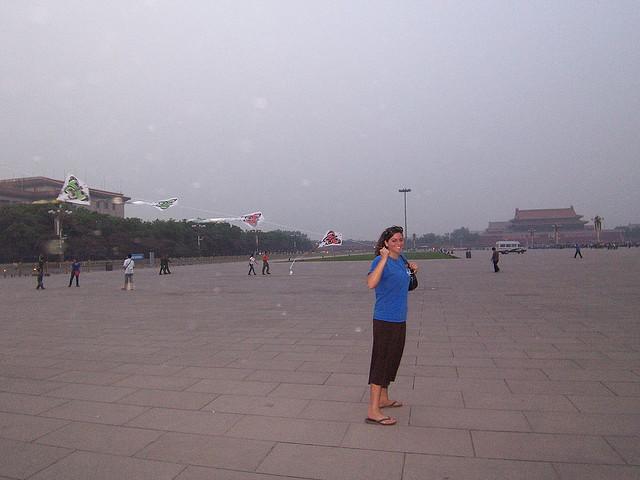What are the marks in the snow?
Concise answer only. No snow. Is she flying her kite in a city park?
Quick response, please. Yes. How many people are in this picture?
Write a very short answer. 10. What hand sign is she making?
Concise answer only. Fist. How many kites are being flown?
Give a very brief answer. 4. Is this what they wore in old days to play ball?
Give a very brief answer. No. Is this lady wearing a dress?
Answer briefly. No. What is cast?
Keep it brief. Overcast. What is the color of the clouds?
Keep it brief. Gray. What is the person standing on?
Short answer required. Ground. What color is the sky?
Concise answer only. Gray. Are these all adults?
Short answer required. Yes. Is the ocean nearby?
Be succinct. No. What is the gender of all the people?
Concise answer only. Female. What is floating?
Short answer required. Kites. Where is the woman standing?
Concise answer only. Plaza. What caused the marks on the concrete in this photograph?
Answer briefly. Tiles. Is this woman wearing white sneakers?
Answer briefly. No. Is the person wearing shoes?
Answer briefly. Yes. 